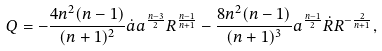<formula> <loc_0><loc_0><loc_500><loc_500>Q = - \frac { 4 n ^ { 2 } ( n - 1 ) } { ( n + 1 ) ^ { 2 } } \dot { a } a ^ { \frac { n - 3 } { 2 } } R ^ { \frac { n - 1 } { n + 1 } } - \frac { 8 n ^ { 2 } ( n - 1 ) } { ( n + 1 ) ^ { 3 } } a ^ { \frac { n - 1 } { 2 } } \dot { R } R ^ { - \frac { 2 } { n + 1 } } ,</formula> 